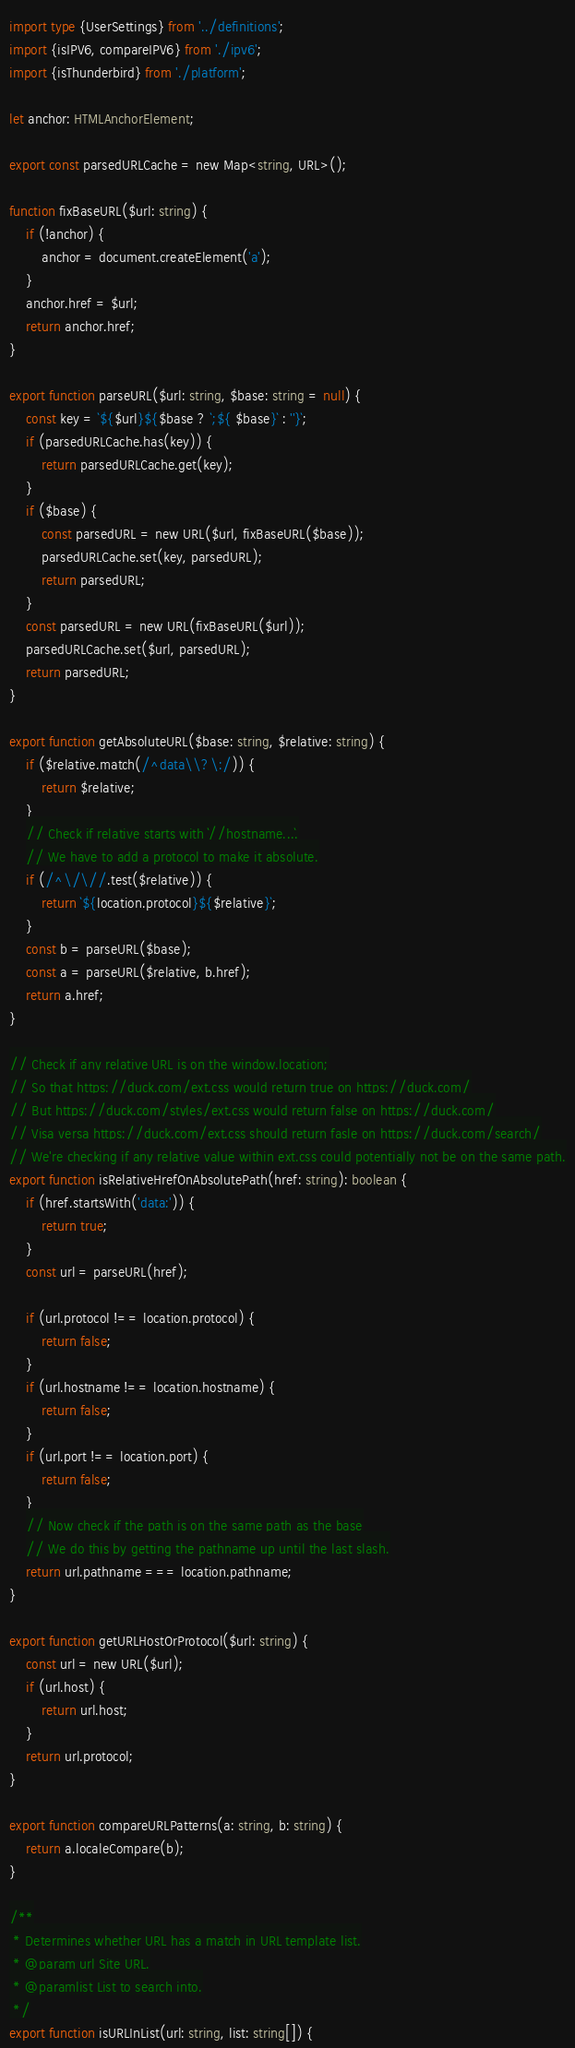Convert code to text. <code><loc_0><loc_0><loc_500><loc_500><_TypeScript_>import type {UserSettings} from '../definitions';
import {isIPV6, compareIPV6} from './ipv6';
import {isThunderbird} from './platform';

let anchor: HTMLAnchorElement;

export const parsedURLCache = new Map<string, URL>();

function fixBaseURL($url: string) {
    if (!anchor) {
        anchor = document.createElement('a');
    }
    anchor.href = $url;
    return anchor.href;
}

export function parseURL($url: string, $base: string = null) {
    const key = `${$url}${$base ? `;${ $base}` : ''}`;
    if (parsedURLCache.has(key)) {
        return parsedURLCache.get(key);
    }
    if ($base) {
        const parsedURL = new URL($url, fixBaseURL($base));
        parsedURLCache.set(key, parsedURL);
        return parsedURL;
    }
    const parsedURL = new URL(fixBaseURL($url));
    parsedURLCache.set($url, parsedURL);
    return parsedURL;
}

export function getAbsoluteURL($base: string, $relative: string) {
    if ($relative.match(/^data\\?\:/)) {
        return $relative;
    }
    // Check if relative starts with `//hostname...`.
    // We have to add a protocol to make it absolute.
    if (/^\/\//.test($relative)) {
        return `${location.protocol}${$relative}`;
    }
    const b = parseURL($base);
    const a = parseURL($relative, b.href);
    return a.href;
}

// Check if any relative URL is on the window.location;
// So that https://duck.com/ext.css would return true on https://duck.com/
// But https://duck.com/styles/ext.css would return false on https://duck.com/
// Visa versa https://duck.com/ext.css should return fasle on https://duck.com/search/
// We're checking if any relative value within ext.css could potentially not be on the same path.
export function isRelativeHrefOnAbsolutePath(href: string): boolean {
    if (href.startsWith('data:')) {
        return true;
    }
    const url = parseURL(href);

    if (url.protocol !== location.protocol) {
        return false;
    }
    if (url.hostname !== location.hostname) {
        return false;
    }
    if (url.port !== location.port) {
        return false;
    }
    // Now check if the path is on the same path as the base
    // We do this by getting the pathname up until the last slash.
    return url.pathname === location.pathname;
}

export function getURLHostOrProtocol($url: string) {
    const url = new URL($url);
    if (url.host) {
        return url.host;
    }
    return url.protocol;
}

export function compareURLPatterns(a: string, b: string) {
    return a.localeCompare(b);
}

/**
 * Determines whether URL has a match in URL template list.
 * @param url Site URL.
 * @paramlist List to search into.
 */
export function isURLInList(url: string, list: string[]) {</code> 